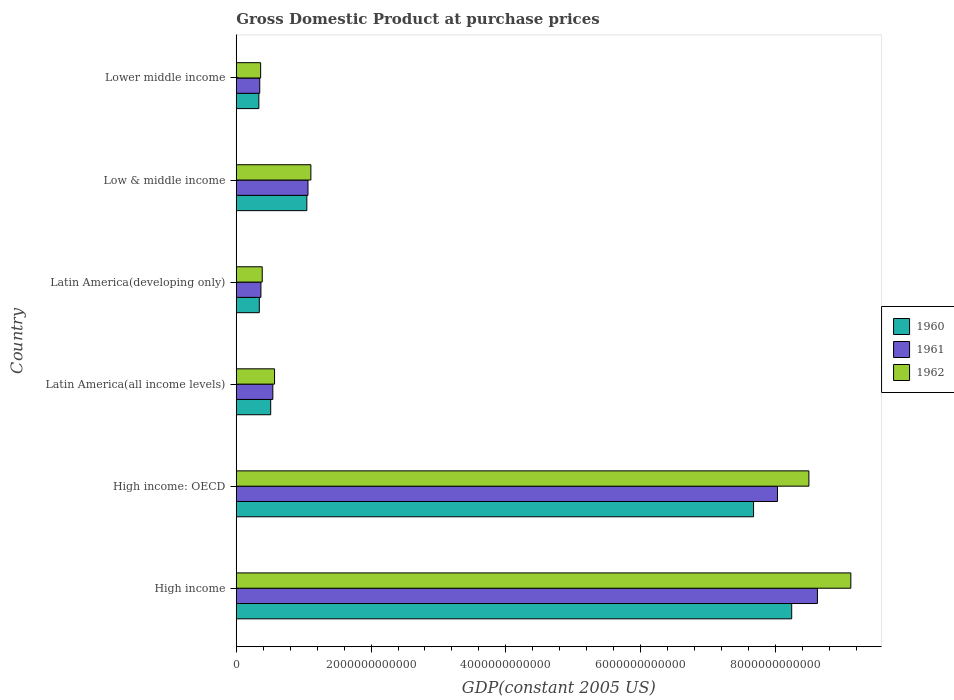How many different coloured bars are there?
Keep it short and to the point. 3. Are the number of bars per tick equal to the number of legend labels?
Offer a terse response. Yes. What is the label of the 3rd group of bars from the top?
Offer a terse response. Latin America(developing only). In how many cases, is the number of bars for a given country not equal to the number of legend labels?
Make the answer very short. 0. What is the GDP at purchase prices in 1960 in High income: OECD?
Give a very brief answer. 7.68e+12. Across all countries, what is the maximum GDP at purchase prices in 1961?
Give a very brief answer. 8.62e+12. Across all countries, what is the minimum GDP at purchase prices in 1962?
Make the answer very short. 3.62e+11. In which country was the GDP at purchase prices in 1960 maximum?
Provide a short and direct response. High income. In which country was the GDP at purchase prices in 1961 minimum?
Give a very brief answer. Lower middle income. What is the total GDP at purchase prices in 1960 in the graph?
Your answer should be compact. 1.82e+13. What is the difference between the GDP at purchase prices in 1962 in High income and that in Latin America(developing only)?
Provide a succinct answer. 8.73e+12. What is the difference between the GDP at purchase prices in 1961 in Lower middle income and the GDP at purchase prices in 1960 in Latin America(developing only)?
Your answer should be very brief. 6.57e+09. What is the average GDP at purchase prices in 1961 per country?
Provide a succinct answer. 3.16e+12. What is the difference between the GDP at purchase prices in 1962 and GDP at purchase prices in 1961 in Lower middle income?
Your answer should be very brief. 1.32e+1. What is the ratio of the GDP at purchase prices in 1961 in High income: OECD to that in Latin America(all income levels)?
Your answer should be compact. 14.79. Is the GDP at purchase prices in 1961 in High income: OECD less than that in Lower middle income?
Your answer should be very brief. No. What is the difference between the highest and the second highest GDP at purchase prices in 1961?
Make the answer very short. 5.93e+11. What is the difference between the highest and the lowest GDP at purchase prices in 1961?
Offer a very short reply. 8.27e+12. In how many countries, is the GDP at purchase prices in 1962 greater than the average GDP at purchase prices in 1962 taken over all countries?
Your answer should be compact. 2. Is the sum of the GDP at purchase prices in 1960 in High income and Low & middle income greater than the maximum GDP at purchase prices in 1961 across all countries?
Make the answer very short. Yes. Is it the case that in every country, the sum of the GDP at purchase prices in 1962 and GDP at purchase prices in 1961 is greater than the GDP at purchase prices in 1960?
Provide a succinct answer. Yes. How many bars are there?
Provide a succinct answer. 18. What is the difference between two consecutive major ticks on the X-axis?
Give a very brief answer. 2.00e+12. Are the values on the major ticks of X-axis written in scientific E-notation?
Keep it short and to the point. No. Does the graph contain any zero values?
Offer a terse response. No. Does the graph contain grids?
Provide a short and direct response. No. What is the title of the graph?
Provide a succinct answer. Gross Domestic Product at purchase prices. Does "1997" appear as one of the legend labels in the graph?
Offer a terse response. No. What is the label or title of the X-axis?
Ensure brevity in your answer.  GDP(constant 2005 US). What is the GDP(constant 2005 US) in 1960 in High income?
Keep it short and to the point. 8.24e+12. What is the GDP(constant 2005 US) of 1961 in High income?
Your response must be concise. 8.62e+12. What is the GDP(constant 2005 US) of 1962 in High income?
Your answer should be compact. 9.12e+12. What is the GDP(constant 2005 US) in 1960 in High income: OECD?
Provide a short and direct response. 7.68e+12. What is the GDP(constant 2005 US) of 1961 in High income: OECD?
Your answer should be very brief. 8.03e+12. What is the GDP(constant 2005 US) in 1962 in High income: OECD?
Keep it short and to the point. 8.50e+12. What is the GDP(constant 2005 US) in 1960 in Latin America(all income levels)?
Give a very brief answer. 5.11e+11. What is the GDP(constant 2005 US) of 1961 in Latin America(all income levels)?
Your response must be concise. 5.43e+11. What is the GDP(constant 2005 US) of 1962 in Latin America(all income levels)?
Make the answer very short. 5.68e+11. What is the GDP(constant 2005 US) in 1960 in Latin America(developing only)?
Your answer should be compact. 3.42e+11. What is the GDP(constant 2005 US) of 1961 in Latin America(developing only)?
Your answer should be very brief. 3.66e+11. What is the GDP(constant 2005 US) of 1962 in Latin America(developing only)?
Your response must be concise. 3.86e+11. What is the GDP(constant 2005 US) in 1960 in Low & middle income?
Provide a succinct answer. 1.05e+12. What is the GDP(constant 2005 US) in 1961 in Low & middle income?
Provide a short and direct response. 1.06e+12. What is the GDP(constant 2005 US) of 1962 in Low & middle income?
Keep it short and to the point. 1.11e+12. What is the GDP(constant 2005 US) in 1960 in Lower middle income?
Give a very brief answer. 3.35e+11. What is the GDP(constant 2005 US) of 1961 in Lower middle income?
Make the answer very short. 3.49e+11. What is the GDP(constant 2005 US) of 1962 in Lower middle income?
Your response must be concise. 3.62e+11. Across all countries, what is the maximum GDP(constant 2005 US) in 1960?
Provide a succinct answer. 8.24e+12. Across all countries, what is the maximum GDP(constant 2005 US) of 1961?
Your answer should be compact. 8.62e+12. Across all countries, what is the maximum GDP(constant 2005 US) in 1962?
Make the answer very short. 9.12e+12. Across all countries, what is the minimum GDP(constant 2005 US) in 1960?
Offer a terse response. 3.35e+11. Across all countries, what is the minimum GDP(constant 2005 US) of 1961?
Your response must be concise. 3.49e+11. Across all countries, what is the minimum GDP(constant 2005 US) in 1962?
Your answer should be very brief. 3.62e+11. What is the total GDP(constant 2005 US) of 1960 in the graph?
Provide a succinct answer. 1.82e+13. What is the total GDP(constant 2005 US) in 1961 in the graph?
Provide a succinct answer. 1.90e+13. What is the total GDP(constant 2005 US) of 1962 in the graph?
Give a very brief answer. 2.00e+13. What is the difference between the GDP(constant 2005 US) in 1960 in High income and that in High income: OECD?
Give a very brief answer. 5.66e+11. What is the difference between the GDP(constant 2005 US) of 1961 in High income and that in High income: OECD?
Make the answer very short. 5.93e+11. What is the difference between the GDP(constant 2005 US) in 1962 in High income and that in High income: OECD?
Make the answer very short. 6.22e+11. What is the difference between the GDP(constant 2005 US) in 1960 in High income and that in Latin America(all income levels)?
Your answer should be very brief. 7.73e+12. What is the difference between the GDP(constant 2005 US) in 1961 in High income and that in Latin America(all income levels)?
Offer a terse response. 8.08e+12. What is the difference between the GDP(constant 2005 US) in 1962 in High income and that in Latin America(all income levels)?
Your answer should be compact. 8.55e+12. What is the difference between the GDP(constant 2005 US) in 1960 in High income and that in Latin America(developing only)?
Your response must be concise. 7.90e+12. What is the difference between the GDP(constant 2005 US) in 1961 in High income and that in Latin America(developing only)?
Offer a very short reply. 8.26e+12. What is the difference between the GDP(constant 2005 US) of 1962 in High income and that in Latin America(developing only)?
Ensure brevity in your answer.  8.73e+12. What is the difference between the GDP(constant 2005 US) in 1960 in High income and that in Low & middle income?
Keep it short and to the point. 7.19e+12. What is the difference between the GDP(constant 2005 US) in 1961 in High income and that in Low & middle income?
Provide a succinct answer. 7.56e+12. What is the difference between the GDP(constant 2005 US) of 1962 in High income and that in Low & middle income?
Offer a very short reply. 8.01e+12. What is the difference between the GDP(constant 2005 US) in 1960 in High income and that in Lower middle income?
Ensure brevity in your answer.  7.91e+12. What is the difference between the GDP(constant 2005 US) of 1961 in High income and that in Lower middle income?
Offer a terse response. 8.27e+12. What is the difference between the GDP(constant 2005 US) in 1962 in High income and that in Lower middle income?
Give a very brief answer. 8.76e+12. What is the difference between the GDP(constant 2005 US) of 1960 in High income: OECD and that in Latin America(all income levels)?
Provide a succinct answer. 7.16e+12. What is the difference between the GDP(constant 2005 US) in 1961 in High income: OECD and that in Latin America(all income levels)?
Your response must be concise. 7.49e+12. What is the difference between the GDP(constant 2005 US) in 1962 in High income: OECD and that in Latin America(all income levels)?
Provide a short and direct response. 7.93e+12. What is the difference between the GDP(constant 2005 US) in 1960 in High income: OECD and that in Latin America(developing only)?
Your answer should be very brief. 7.33e+12. What is the difference between the GDP(constant 2005 US) of 1961 in High income: OECD and that in Latin America(developing only)?
Your response must be concise. 7.66e+12. What is the difference between the GDP(constant 2005 US) of 1962 in High income: OECD and that in Latin America(developing only)?
Offer a very short reply. 8.11e+12. What is the difference between the GDP(constant 2005 US) of 1960 in High income: OECD and that in Low & middle income?
Your response must be concise. 6.63e+12. What is the difference between the GDP(constant 2005 US) of 1961 in High income: OECD and that in Low & middle income?
Give a very brief answer. 6.97e+12. What is the difference between the GDP(constant 2005 US) of 1962 in High income: OECD and that in Low & middle income?
Keep it short and to the point. 7.39e+12. What is the difference between the GDP(constant 2005 US) of 1960 in High income: OECD and that in Lower middle income?
Provide a short and direct response. 7.34e+12. What is the difference between the GDP(constant 2005 US) of 1961 in High income: OECD and that in Lower middle income?
Your answer should be very brief. 7.68e+12. What is the difference between the GDP(constant 2005 US) in 1962 in High income: OECD and that in Lower middle income?
Your answer should be very brief. 8.13e+12. What is the difference between the GDP(constant 2005 US) of 1960 in Latin America(all income levels) and that in Latin America(developing only)?
Make the answer very short. 1.69e+11. What is the difference between the GDP(constant 2005 US) in 1961 in Latin America(all income levels) and that in Latin America(developing only)?
Provide a short and direct response. 1.77e+11. What is the difference between the GDP(constant 2005 US) in 1962 in Latin America(all income levels) and that in Latin America(developing only)?
Offer a terse response. 1.83e+11. What is the difference between the GDP(constant 2005 US) in 1960 in Latin America(all income levels) and that in Low & middle income?
Offer a very short reply. -5.37e+11. What is the difference between the GDP(constant 2005 US) of 1961 in Latin America(all income levels) and that in Low & middle income?
Provide a short and direct response. -5.21e+11. What is the difference between the GDP(constant 2005 US) in 1962 in Latin America(all income levels) and that in Low & middle income?
Offer a terse response. -5.39e+11. What is the difference between the GDP(constant 2005 US) of 1960 in Latin America(all income levels) and that in Lower middle income?
Offer a very short reply. 1.75e+11. What is the difference between the GDP(constant 2005 US) of 1961 in Latin America(all income levels) and that in Lower middle income?
Your answer should be compact. 1.94e+11. What is the difference between the GDP(constant 2005 US) in 1962 in Latin America(all income levels) and that in Lower middle income?
Give a very brief answer. 2.06e+11. What is the difference between the GDP(constant 2005 US) of 1960 in Latin America(developing only) and that in Low & middle income?
Offer a very short reply. -7.05e+11. What is the difference between the GDP(constant 2005 US) of 1961 in Latin America(developing only) and that in Low & middle income?
Make the answer very short. -6.98e+11. What is the difference between the GDP(constant 2005 US) of 1962 in Latin America(developing only) and that in Low & middle income?
Your response must be concise. -7.22e+11. What is the difference between the GDP(constant 2005 US) in 1960 in Latin America(developing only) and that in Lower middle income?
Your response must be concise. 6.59e+09. What is the difference between the GDP(constant 2005 US) in 1961 in Latin America(developing only) and that in Lower middle income?
Offer a very short reply. 1.73e+1. What is the difference between the GDP(constant 2005 US) of 1962 in Latin America(developing only) and that in Lower middle income?
Offer a very short reply. 2.38e+1. What is the difference between the GDP(constant 2005 US) of 1960 in Low & middle income and that in Lower middle income?
Your answer should be very brief. 7.12e+11. What is the difference between the GDP(constant 2005 US) of 1961 in Low & middle income and that in Lower middle income?
Your response must be concise. 7.16e+11. What is the difference between the GDP(constant 2005 US) of 1962 in Low & middle income and that in Lower middle income?
Give a very brief answer. 7.46e+11. What is the difference between the GDP(constant 2005 US) of 1960 in High income and the GDP(constant 2005 US) of 1961 in High income: OECD?
Make the answer very short. 2.11e+11. What is the difference between the GDP(constant 2005 US) of 1960 in High income and the GDP(constant 2005 US) of 1962 in High income: OECD?
Make the answer very short. -2.55e+11. What is the difference between the GDP(constant 2005 US) of 1961 in High income and the GDP(constant 2005 US) of 1962 in High income: OECD?
Offer a terse response. 1.27e+11. What is the difference between the GDP(constant 2005 US) in 1960 in High income and the GDP(constant 2005 US) in 1961 in Latin America(all income levels)?
Ensure brevity in your answer.  7.70e+12. What is the difference between the GDP(constant 2005 US) in 1960 in High income and the GDP(constant 2005 US) in 1962 in Latin America(all income levels)?
Provide a short and direct response. 7.67e+12. What is the difference between the GDP(constant 2005 US) in 1961 in High income and the GDP(constant 2005 US) in 1962 in Latin America(all income levels)?
Keep it short and to the point. 8.06e+12. What is the difference between the GDP(constant 2005 US) of 1960 in High income and the GDP(constant 2005 US) of 1961 in Latin America(developing only)?
Offer a terse response. 7.88e+12. What is the difference between the GDP(constant 2005 US) in 1960 in High income and the GDP(constant 2005 US) in 1962 in Latin America(developing only)?
Your response must be concise. 7.86e+12. What is the difference between the GDP(constant 2005 US) of 1961 in High income and the GDP(constant 2005 US) of 1962 in Latin America(developing only)?
Your answer should be very brief. 8.24e+12. What is the difference between the GDP(constant 2005 US) in 1960 in High income and the GDP(constant 2005 US) in 1961 in Low & middle income?
Your response must be concise. 7.18e+12. What is the difference between the GDP(constant 2005 US) of 1960 in High income and the GDP(constant 2005 US) of 1962 in Low & middle income?
Provide a succinct answer. 7.13e+12. What is the difference between the GDP(constant 2005 US) of 1961 in High income and the GDP(constant 2005 US) of 1962 in Low & middle income?
Offer a very short reply. 7.52e+12. What is the difference between the GDP(constant 2005 US) in 1960 in High income and the GDP(constant 2005 US) in 1961 in Lower middle income?
Keep it short and to the point. 7.89e+12. What is the difference between the GDP(constant 2005 US) of 1960 in High income and the GDP(constant 2005 US) of 1962 in Lower middle income?
Make the answer very short. 7.88e+12. What is the difference between the GDP(constant 2005 US) of 1961 in High income and the GDP(constant 2005 US) of 1962 in Lower middle income?
Give a very brief answer. 8.26e+12. What is the difference between the GDP(constant 2005 US) in 1960 in High income: OECD and the GDP(constant 2005 US) in 1961 in Latin America(all income levels)?
Give a very brief answer. 7.13e+12. What is the difference between the GDP(constant 2005 US) in 1960 in High income: OECD and the GDP(constant 2005 US) in 1962 in Latin America(all income levels)?
Your response must be concise. 7.11e+12. What is the difference between the GDP(constant 2005 US) of 1961 in High income: OECD and the GDP(constant 2005 US) of 1962 in Latin America(all income levels)?
Keep it short and to the point. 7.46e+12. What is the difference between the GDP(constant 2005 US) of 1960 in High income: OECD and the GDP(constant 2005 US) of 1961 in Latin America(developing only)?
Your response must be concise. 7.31e+12. What is the difference between the GDP(constant 2005 US) of 1960 in High income: OECD and the GDP(constant 2005 US) of 1962 in Latin America(developing only)?
Provide a short and direct response. 7.29e+12. What is the difference between the GDP(constant 2005 US) in 1961 in High income: OECD and the GDP(constant 2005 US) in 1962 in Latin America(developing only)?
Offer a very short reply. 7.64e+12. What is the difference between the GDP(constant 2005 US) in 1960 in High income: OECD and the GDP(constant 2005 US) in 1961 in Low & middle income?
Give a very brief answer. 6.61e+12. What is the difference between the GDP(constant 2005 US) of 1960 in High income: OECD and the GDP(constant 2005 US) of 1962 in Low & middle income?
Offer a very short reply. 6.57e+12. What is the difference between the GDP(constant 2005 US) of 1961 in High income: OECD and the GDP(constant 2005 US) of 1962 in Low & middle income?
Your response must be concise. 6.92e+12. What is the difference between the GDP(constant 2005 US) of 1960 in High income: OECD and the GDP(constant 2005 US) of 1961 in Lower middle income?
Ensure brevity in your answer.  7.33e+12. What is the difference between the GDP(constant 2005 US) of 1960 in High income: OECD and the GDP(constant 2005 US) of 1962 in Lower middle income?
Provide a succinct answer. 7.31e+12. What is the difference between the GDP(constant 2005 US) in 1961 in High income: OECD and the GDP(constant 2005 US) in 1962 in Lower middle income?
Provide a succinct answer. 7.67e+12. What is the difference between the GDP(constant 2005 US) of 1960 in Latin America(all income levels) and the GDP(constant 2005 US) of 1961 in Latin America(developing only)?
Offer a very short reply. 1.45e+11. What is the difference between the GDP(constant 2005 US) in 1960 in Latin America(all income levels) and the GDP(constant 2005 US) in 1962 in Latin America(developing only)?
Offer a very short reply. 1.25e+11. What is the difference between the GDP(constant 2005 US) of 1961 in Latin America(all income levels) and the GDP(constant 2005 US) of 1962 in Latin America(developing only)?
Provide a succinct answer. 1.57e+11. What is the difference between the GDP(constant 2005 US) of 1960 in Latin America(all income levels) and the GDP(constant 2005 US) of 1961 in Low & middle income?
Keep it short and to the point. -5.53e+11. What is the difference between the GDP(constant 2005 US) in 1960 in Latin America(all income levels) and the GDP(constant 2005 US) in 1962 in Low & middle income?
Keep it short and to the point. -5.96e+11. What is the difference between the GDP(constant 2005 US) of 1961 in Latin America(all income levels) and the GDP(constant 2005 US) of 1962 in Low & middle income?
Your response must be concise. -5.64e+11. What is the difference between the GDP(constant 2005 US) of 1960 in Latin America(all income levels) and the GDP(constant 2005 US) of 1961 in Lower middle income?
Offer a terse response. 1.62e+11. What is the difference between the GDP(constant 2005 US) in 1960 in Latin America(all income levels) and the GDP(constant 2005 US) in 1962 in Lower middle income?
Provide a short and direct response. 1.49e+11. What is the difference between the GDP(constant 2005 US) in 1961 in Latin America(all income levels) and the GDP(constant 2005 US) in 1962 in Lower middle income?
Offer a very short reply. 1.81e+11. What is the difference between the GDP(constant 2005 US) in 1960 in Latin America(developing only) and the GDP(constant 2005 US) in 1961 in Low & middle income?
Offer a very short reply. -7.22e+11. What is the difference between the GDP(constant 2005 US) of 1960 in Latin America(developing only) and the GDP(constant 2005 US) of 1962 in Low & middle income?
Make the answer very short. -7.65e+11. What is the difference between the GDP(constant 2005 US) in 1961 in Latin America(developing only) and the GDP(constant 2005 US) in 1962 in Low & middle income?
Your answer should be compact. -7.41e+11. What is the difference between the GDP(constant 2005 US) in 1960 in Latin America(developing only) and the GDP(constant 2005 US) in 1961 in Lower middle income?
Offer a very short reply. -6.57e+09. What is the difference between the GDP(constant 2005 US) in 1960 in Latin America(developing only) and the GDP(constant 2005 US) in 1962 in Lower middle income?
Provide a succinct answer. -1.97e+1. What is the difference between the GDP(constant 2005 US) in 1961 in Latin America(developing only) and the GDP(constant 2005 US) in 1962 in Lower middle income?
Ensure brevity in your answer.  4.17e+09. What is the difference between the GDP(constant 2005 US) in 1960 in Low & middle income and the GDP(constant 2005 US) in 1961 in Lower middle income?
Provide a succinct answer. 6.99e+11. What is the difference between the GDP(constant 2005 US) of 1960 in Low & middle income and the GDP(constant 2005 US) of 1962 in Lower middle income?
Provide a short and direct response. 6.86e+11. What is the difference between the GDP(constant 2005 US) of 1961 in Low & middle income and the GDP(constant 2005 US) of 1962 in Lower middle income?
Provide a succinct answer. 7.03e+11. What is the average GDP(constant 2005 US) in 1960 per country?
Offer a terse response. 3.03e+12. What is the average GDP(constant 2005 US) in 1961 per country?
Give a very brief answer. 3.16e+12. What is the average GDP(constant 2005 US) of 1962 per country?
Keep it short and to the point. 3.34e+12. What is the difference between the GDP(constant 2005 US) of 1960 and GDP(constant 2005 US) of 1961 in High income?
Give a very brief answer. -3.82e+11. What is the difference between the GDP(constant 2005 US) in 1960 and GDP(constant 2005 US) in 1962 in High income?
Offer a terse response. -8.77e+11. What is the difference between the GDP(constant 2005 US) of 1961 and GDP(constant 2005 US) of 1962 in High income?
Provide a short and direct response. -4.95e+11. What is the difference between the GDP(constant 2005 US) of 1960 and GDP(constant 2005 US) of 1961 in High income: OECD?
Keep it short and to the point. -3.55e+11. What is the difference between the GDP(constant 2005 US) in 1960 and GDP(constant 2005 US) in 1962 in High income: OECD?
Ensure brevity in your answer.  -8.21e+11. What is the difference between the GDP(constant 2005 US) in 1961 and GDP(constant 2005 US) in 1962 in High income: OECD?
Provide a short and direct response. -4.66e+11. What is the difference between the GDP(constant 2005 US) of 1960 and GDP(constant 2005 US) of 1961 in Latin America(all income levels)?
Your answer should be compact. -3.20e+1. What is the difference between the GDP(constant 2005 US) in 1960 and GDP(constant 2005 US) in 1962 in Latin America(all income levels)?
Offer a terse response. -5.72e+1. What is the difference between the GDP(constant 2005 US) of 1961 and GDP(constant 2005 US) of 1962 in Latin America(all income levels)?
Your answer should be compact. -2.51e+1. What is the difference between the GDP(constant 2005 US) of 1960 and GDP(constant 2005 US) of 1961 in Latin America(developing only)?
Keep it short and to the point. -2.39e+1. What is the difference between the GDP(constant 2005 US) in 1960 and GDP(constant 2005 US) in 1962 in Latin America(developing only)?
Your response must be concise. -4.35e+1. What is the difference between the GDP(constant 2005 US) of 1961 and GDP(constant 2005 US) of 1962 in Latin America(developing only)?
Offer a terse response. -1.96e+1. What is the difference between the GDP(constant 2005 US) in 1960 and GDP(constant 2005 US) in 1961 in Low & middle income?
Keep it short and to the point. -1.68e+1. What is the difference between the GDP(constant 2005 US) in 1960 and GDP(constant 2005 US) in 1962 in Low & middle income?
Your response must be concise. -5.98e+1. What is the difference between the GDP(constant 2005 US) of 1961 and GDP(constant 2005 US) of 1962 in Low & middle income?
Keep it short and to the point. -4.30e+1. What is the difference between the GDP(constant 2005 US) of 1960 and GDP(constant 2005 US) of 1961 in Lower middle income?
Provide a succinct answer. -1.32e+1. What is the difference between the GDP(constant 2005 US) of 1960 and GDP(constant 2005 US) of 1962 in Lower middle income?
Give a very brief answer. -2.63e+1. What is the difference between the GDP(constant 2005 US) of 1961 and GDP(constant 2005 US) of 1962 in Lower middle income?
Ensure brevity in your answer.  -1.32e+1. What is the ratio of the GDP(constant 2005 US) of 1960 in High income to that in High income: OECD?
Ensure brevity in your answer.  1.07. What is the ratio of the GDP(constant 2005 US) in 1961 in High income to that in High income: OECD?
Offer a terse response. 1.07. What is the ratio of the GDP(constant 2005 US) of 1962 in High income to that in High income: OECD?
Give a very brief answer. 1.07. What is the ratio of the GDP(constant 2005 US) of 1960 in High income to that in Latin America(all income levels)?
Make the answer very short. 16.13. What is the ratio of the GDP(constant 2005 US) of 1961 in High income to that in Latin America(all income levels)?
Provide a succinct answer. 15.88. What is the ratio of the GDP(constant 2005 US) in 1962 in High income to that in Latin America(all income levels)?
Your answer should be compact. 16.05. What is the ratio of the GDP(constant 2005 US) in 1960 in High income to that in Latin America(developing only)?
Provide a succinct answer. 24.1. What is the ratio of the GDP(constant 2005 US) in 1961 in High income to that in Latin America(developing only)?
Ensure brevity in your answer.  23.57. What is the ratio of the GDP(constant 2005 US) of 1962 in High income to that in Latin America(developing only)?
Your answer should be compact. 23.65. What is the ratio of the GDP(constant 2005 US) of 1960 in High income to that in Low & middle income?
Offer a terse response. 7.87. What is the ratio of the GDP(constant 2005 US) of 1961 in High income to that in Low & middle income?
Offer a very short reply. 8.1. What is the ratio of the GDP(constant 2005 US) of 1962 in High income to that in Low & middle income?
Your response must be concise. 8.24. What is the ratio of the GDP(constant 2005 US) of 1960 in High income to that in Lower middle income?
Keep it short and to the point. 24.57. What is the ratio of the GDP(constant 2005 US) in 1961 in High income to that in Lower middle income?
Keep it short and to the point. 24.74. What is the ratio of the GDP(constant 2005 US) in 1962 in High income to that in Lower middle income?
Ensure brevity in your answer.  25.21. What is the ratio of the GDP(constant 2005 US) in 1960 in High income: OECD to that in Latin America(all income levels)?
Your answer should be compact. 15.02. What is the ratio of the GDP(constant 2005 US) of 1961 in High income: OECD to that in Latin America(all income levels)?
Offer a terse response. 14.79. What is the ratio of the GDP(constant 2005 US) of 1962 in High income: OECD to that in Latin America(all income levels)?
Your answer should be very brief. 14.96. What is the ratio of the GDP(constant 2005 US) in 1960 in High income: OECD to that in Latin America(developing only)?
Offer a very short reply. 22.44. What is the ratio of the GDP(constant 2005 US) of 1961 in High income: OECD to that in Latin America(developing only)?
Keep it short and to the point. 21.95. What is the ratio of the GDP(constant 2005 US) in 1962 in High income: OECD to that in Latin America(developing only)?
Give a very brief answer. 22.04. What is the ratio of the GDP(constant 2005 US) in 1960 in High income: OECD to that in Low & middle income?
Give a very brief answer. 7.33. What is the ratio of the GDP(constant 2005 US) in 1961 in High income: OECD to that in Low & middle income?
Offer a very short reply. 7.55. What is the ratio of the GDP(constant 2005 US) of 1962 in High income: OECD to that in Low & middle income?
Your answer should be compact. 7.67. What is the ratio of the GDP(constant 2005 US) of 1960 in High income: OECD to that in Lower middle income?
Ensure brevity in your answer.  22.88. What is the ratio of the GDP(constant 2005 US) in 1961 in High income: OECD to that in Lower middle income?
Offer a very short reply. 23.04. What is the ratio of the GDP(constant 2005 US) of 1962 in High income: OECD to that in Lower middle income?
Your answer should be compact. 23.49. What is the ratio of the GDP(constant 2005 US) in 1960 in Latin America(all income levels) to that in Latin America(developing only)?
Keep it short and to the point. 1.49. What is the ratio of the GDP(constant 2005 US) in 1961 in Latin America(all income levels) to that in Latin America(developing only)?
Your answer should be compact. 1.48. What is the ratio of the GDP(constant 2005 US) of 1962 in Latin America(all income levels) to that in Latin America(developing only)?
Provide a short and direct response. 1.47. What is the ratio of the GDP(constant 2005 US) of 1960 in Latin America(all income levels) to that in Low & middle income?
Your answer should be compact. 0.49. What is the ratio of the GDP(constant 2005 US) of 1961 in Latin America(all income levels) to that in Low & middle income?
Your answer should be compact. 0.51. What is the ratio of the GDP(constant 2005 US) of 1962 in Latin America(all income levels) to that in Low & middle income?
Your answer should be compact. 0.51. What is the ratio of the GDP(constant 2005 US) of 1960 in Latin America(all income levels) to that in Lower middle income?
Provide a succinct answer. 1.52. What is the ratio of the GDP(constant 2005 US) of 1961 in Latin America(all income levels) to that in Lower middle income?
Provide a succinct answer. 1.56. What is the ratio of the GDP(constant 2005 US) of 1962 in Latin America(all income levels) to that in Lower middle income?
Give a very brief answer. 1.57. What is the ratio of the GDP(constant 2005 US) in 1960 in Latin America(developing only) to that in Low & middle income?
Offer a terse response. 0.33. What is the ratio of the GDP(constant 2005 US) of 1961 in Latin America(developing only) to that in Low & middle income?
Give a very brief answer. 0.34. What is the ratio of the GDP(constant 2005 US) of 1962 in Latin America(developing only) to that in Low & middle income?
Provide a short and direct response. 0.35. What is the ratio of the GDP(constant 2005 US) in 1960 in Latin America(developing only) to that in Lower middle income?
Keep it short and to the point. 1.02. What is the ratio of the GDP(constant 2005 US) in 1961 in Latin America(developing only) to that in Lower middle income?
Your response must be concise. 1.05. What is the ratio of the GDP(constant 2005 US) in 1962 in Latin America(developing only) to that in Lower middle income?
Your answer should be very brief. 1.07. What is the ratio of the GDP(constant 2005 US) of 1960 in Low & middle income to that in Lower middle income?
Your response must be concise. 3.12. What is the ratio of the GDP(constant 2005 US) in 1961 in Low & middle income to that in Lower middle income?
Keep it short and to the point. 3.05. What is the ratio of the GDP(constant 2005 US) of 1962 in Low & middle income to that in Lower middle income?
Your answer should be compact. 3.06. What is the difference between the highest and the second highest GDP(constant 2005 US) in 1960?
Offer a terse response. 5.66e+11. What is the difference between the highest and the second highest GDP(constant 2005 US) of 1961?
Your response must be concise. 5.93e+11. What is the difference between the highest and the second highest GDP(constant 2005 US) of 1962?
Offer a very short reply. 6.22e+11. What is the difference between the highest and the lowest GDP(constant 2005 US) in 1960?
Provide a succinct answer. 7.91e+12. What is the difference between the highest and the lowest GDP(constant 2005 US) of 1961?
Provide a succinct answer. 8.27e+12. What is the difference between the highest and the lowest GDP(constant 2005 US) in 1962?
Keep it short and to the point. 8.76e+12. 